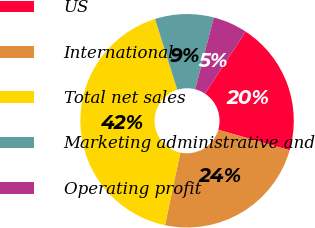<chart> <loc_0><loc_0><loc_500><loc_500><pie_chart><fcel>US<fcel>International<fcel>Total net sales<fcel>Marketing administrative and<fcel>Operating profit<nl><fcel>20.2%<fcel>23.86%<fcel>41.83%<fcel>8.89%<fcel>5.23%<nl></chart> 